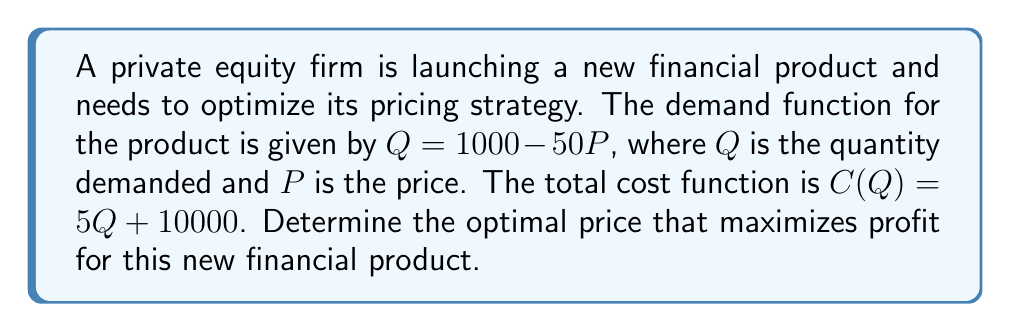Can you answer this question? To solve this optimization problem, we'll follow these steps:

1) First, let's express the profit function in terms of P:
   Profit = Revenue - Cost
   $\pi(P) = PQ - C(Q)$

2) Substitute the demand function and cost function:
   $\pi(P) = P(1000 - 50P) - [5(1000 - 50P) + 10000]$

3) Expand the equation:
   $\pi(P) = 1000P - 50P^2 - 5000 + 250P - 10000$
   $\pi(P) = -50P^2 + 1250P - 15000$

4) To find the maximum profit, we need to find where the derivative of the profit function equals zero:
   $\frac{d\pi}{dP} = -100P + 1250 = 0$

5) Solve for P:
   $-100P = -1250$
   $P = 12.5$

6) To confirm this is a maximum (not a minimum), check the second derivative:
   $\frac{d^2\pi}{dP^2} = -100$, which is negative, confirming a maximum.

7) Calculate the maximum profit:
   $\pi(12.5) = -50(12.5)^2 + 1250(12.5) - 15000$
   $= -7812.5 + 15625 - 15000$
   $= -7187.5$

Therefore, the optimal price that maximizes profit is $12.5.
Answer: The optimal price that maximizes profit for the new financial product is $12.5. 